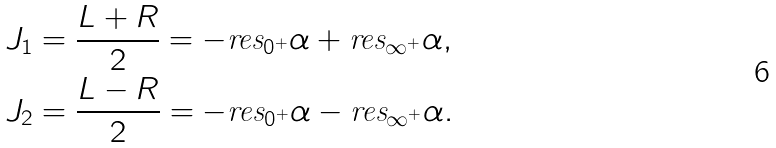Convert formula to latex. <formula><loc_0><loc_0><loc_500><loc_500>J _ { 1 } & = \frac { L + R } { 2 } = - \text {res} _ { 0 ^ { + } } \alpha + \text {res} _ { \infty ^ { + } } \alpha , \\ J _ { 2 } & = \frac { L - R } { 2 } = - \text {res} _ { 0 ^ { + } } \alpha - \text {res} _ { \infty ^ { + } } \alpha .</formula> 